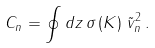Convert formula to latex. <formula><loc_0><loc_0><loc_500><loc_500>C _ { n } = \oint d z \, \sigma \left ( K \right ) \, { \tilde { v } } _ { n } ^ { 2 } \, .</formula> 